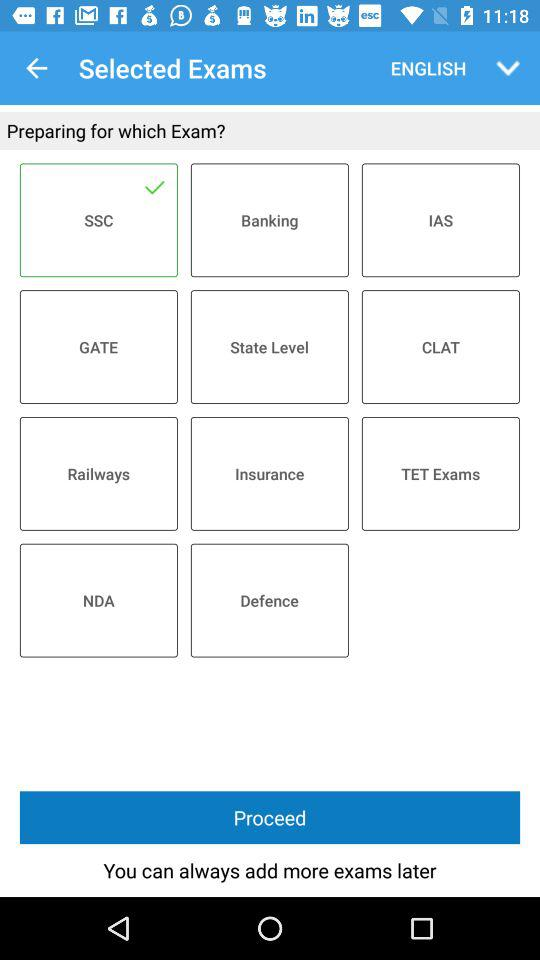Which exam has been selected? The exam that has been selected is SSC. 